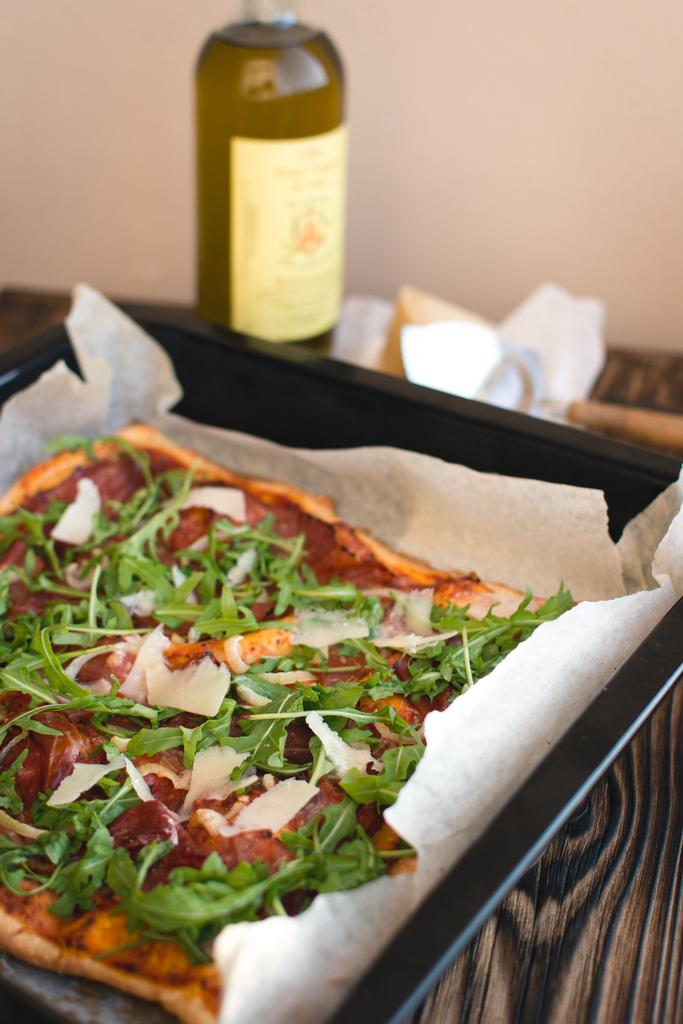What is the main object on the table in the image? There is a food item on the table in the image. What else can be seen beside the food item on the table? There is a bottle beside the plate on the table in the image. Are there any visible signs of blood on the food item in the image? No, there are no visible signs of blood on the food item in the image. 